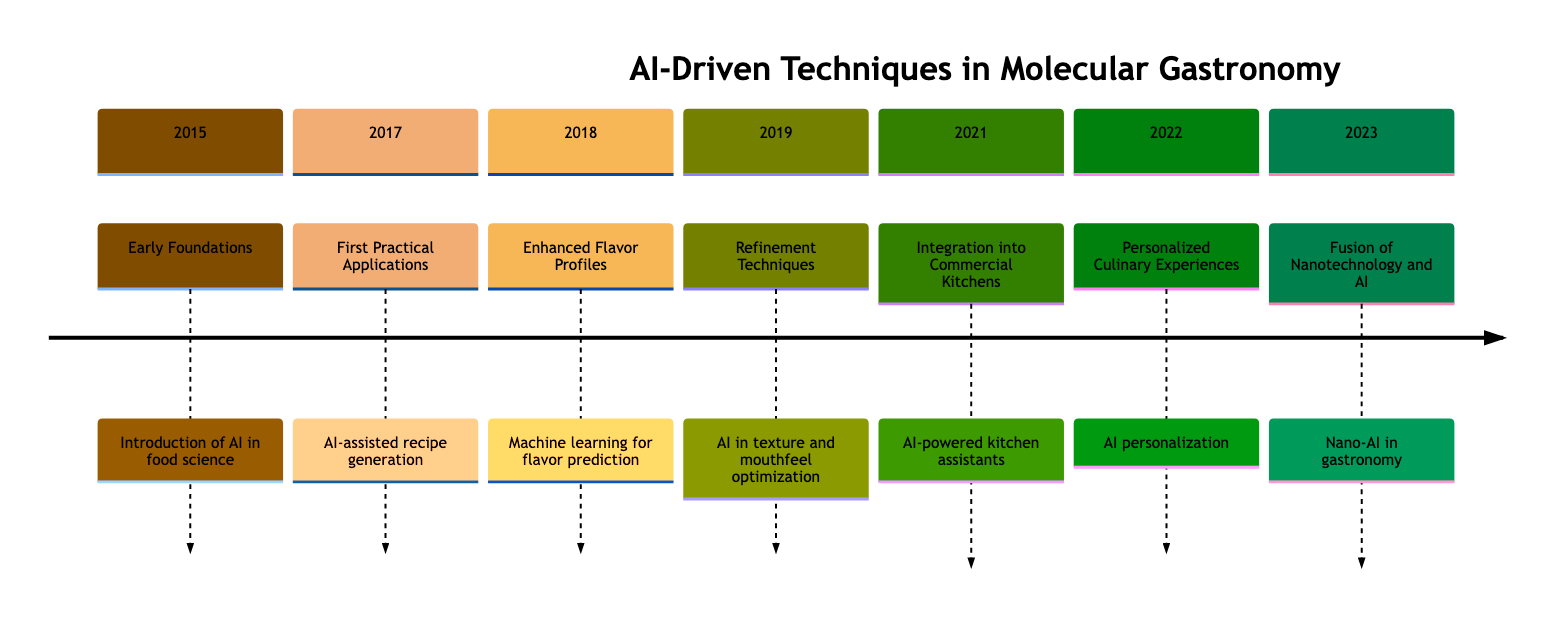What year was the introduction of AI in food science? The timeline indicates that the introduction of AI in food science occurred in 2015, which is explicitly mentioned in the "Early Foundations" section.
Answer: 2015 What is the event described in 2018? The 2018 section titled "Enhanced Flavor Profiles" describes the event as "Machine learning for flavor prediction," which provides enough information to answer the question directly.
Answer: Machine learning for flavor prediction How many years are between the first practical applications and the integration into commercial kitchens? The first practical application occurs in 2017 and integration into commercial kitchens occurs in 2021. Calculating the difference gives 2021 - 2017 = 4 years.
Answer: 4 years What is the main focus of the 2023 event? Referring to the section labeled "Fusion of Nanotechnology and AI," the main focus of the 2023 event is detailed as "Exploration of integrating nanotechnology with AI into innovative cooking techniques." This description confirms the focus.
Answer: Integration of nanotechnology with AI Which technology was implemented to create personalized culinary experiences in 2022? The event in 2022 is titled "AI personalization," which clearly indicates that AI was the technology implemented for creating personalized culinary experiences based on taste preferences.
Answer: AI How does the refinement techniques event relate to texture in 2019? The event in 2019 labeled "Refinement Techniques" describes AI's role in optimizing "textures and mouthfeels," emphasizing that the connection is about improving the textural quality of dishes.
Answer: Optimizing textures and mouthfeels What significant development happened in cooking processes by 2021? The timeline notes that "Integration into Commercial Kitchens" occurred in 2021, highlighting that AI-powered kitchen assistants were introduced, which indicates a significant advancement in the cooking processes.
Answer: AI-powered kitchen assistants What timeline year saw the start of AI-assisted recipe generation? The section titled "First Practical Applications" clearly states that AI-assisted recipe generation began in 2017, which addresses the specific temporal question directly.
Answer: 2017 How did machine learning contribute to flavor profiling in 2018? In 2018, the event described as "Machine learning for flavor prediction" suggests that ML was used to predict and enhance the flavor profiles of dishes, indicating a direct contribution to flavor profiling techniques.
Answer: Enhance flavor profiles 